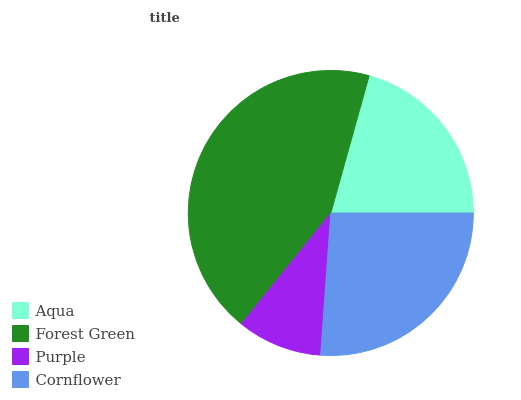Is Purple the minimum?
Answer yes or no. Yes. Is Forest Green the maximum?
Answer yes or no. Yes. Is Forest Green the minimum?
Answer yes or no. No. Is Purple the maximum?
Answer yes or no. No. Is Forest Green greater than Purple?
Answer yes or no. Yes. Is Purple less than Forest Green?
Answer yes or no. Yes. Is Purple greater than Forest Green?
Answer yes or no. No. Is Forest Green less than Purple?
Answer yes or no. No. Is Cornflower the high median?
Answer yes or no. Yes. Is Aqua the low median?
Answer yes or no. Yes. Is Purple the high median?
Answer yes or no. No. Is Forest Green the low median?
Answer yes or no. No. 